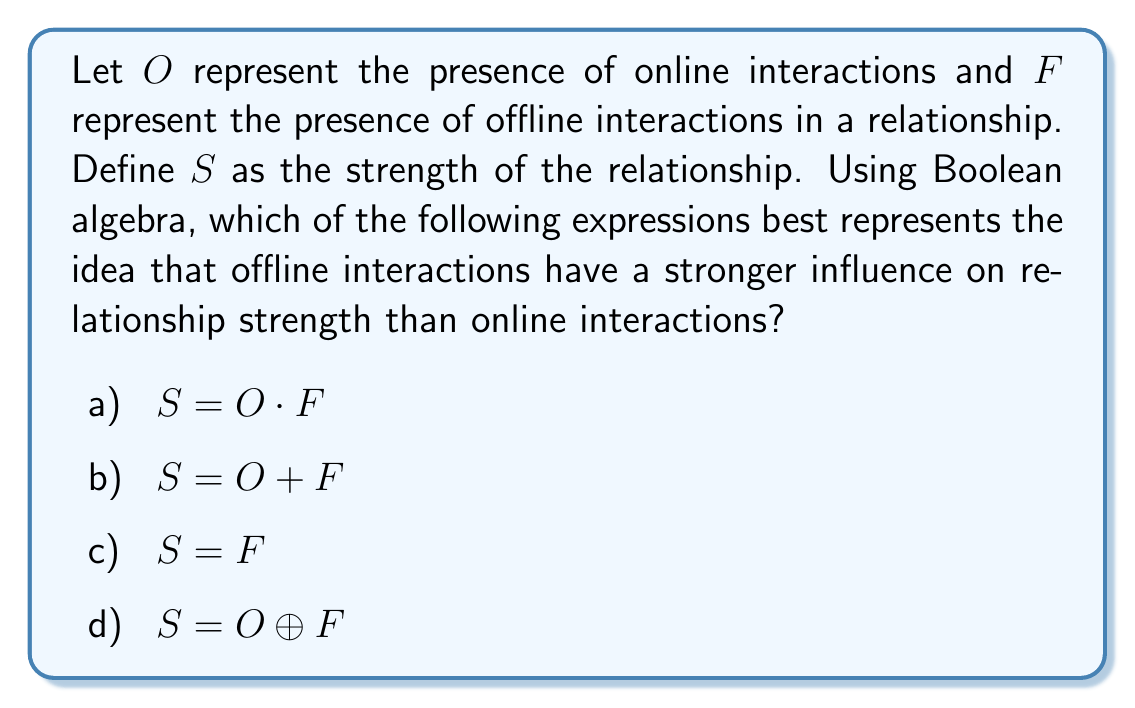What is the answer to this math problem? To analyze this problem, let's consider each option:

1) $S = O \cdot F$:
   This expression uses the AND operation, implying that both online and offline interactions are necessary for relationship strength. While this may be true in some cases, it doesn't capture the idea that offline interactions have a stronger influence.

2) $S = O + F$:
   This expression uses the OR operation, suggesting that either online or offline interactions contribute equally to relationship strength. This doesn't align with the given perspective that offline factors are more influential.

3) $S = F$:
   This expression directly equates relationship strength to offline interactions, completely disregarding online interactions. This aligns most closely with the given perspective that offline factors are more influential on interpersonal relationships.

4) $S = O \oplus F$:
   This expression uses the XOR operation, implying that relationship strength is present when either online or offline interactions are present, but not both. This doesn't accurately represent the given perspective.

Given the psychologist's argument that interpersonal relationships are more influenced by offline factors than online, option c) $S = F$ best represents this idea in Boolean algebraic terms. It emphasizes the primacy of offline interactions in determining relationship strength, which aligns with the given perspective.
Answer: c) $S = F$ 